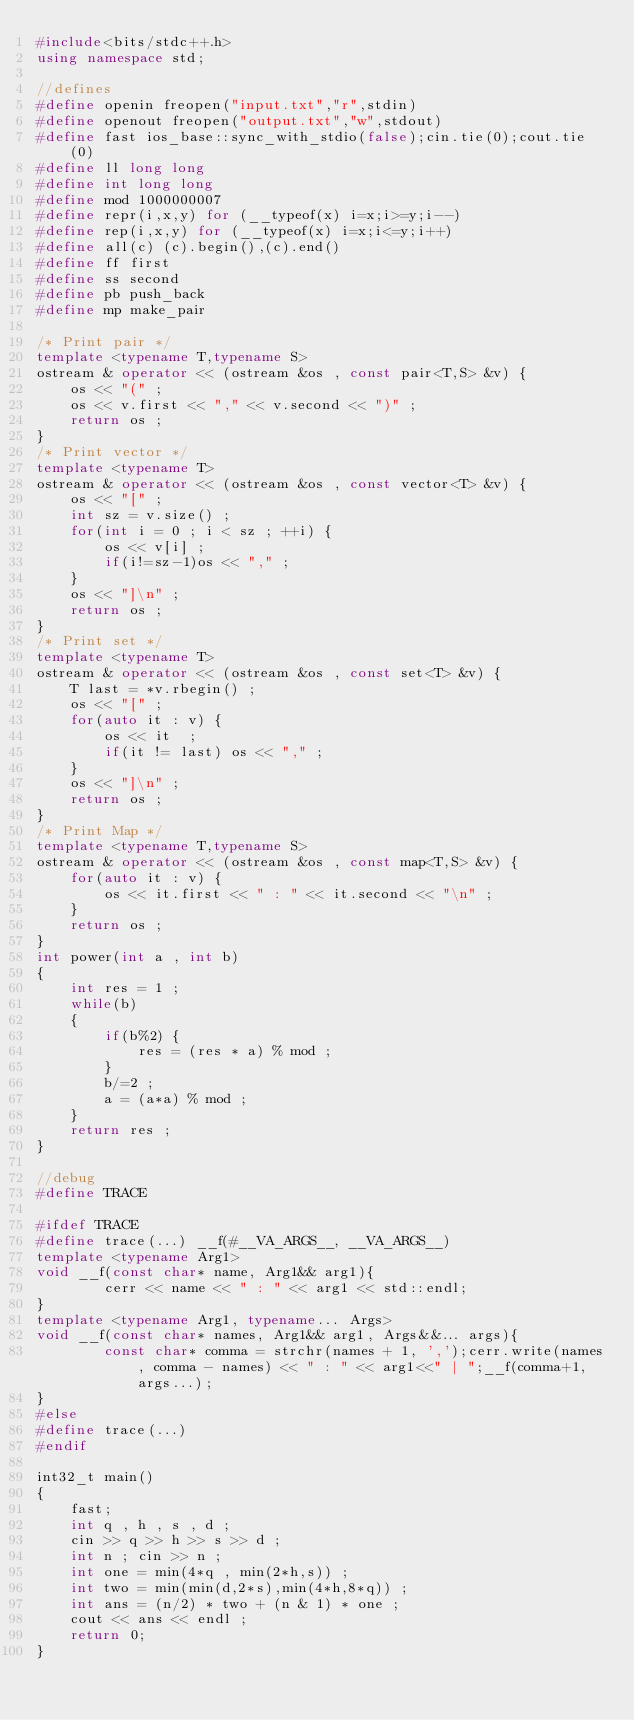Convert code to text. <code><loc_0><loc_0><loc_500><loc_500><_C++_>#include<bits/stdc++.h>
using namespace std;

//defines
#define openin freopen("input.txt","r",stdin)
#define openout freopen("output.txt","w",stdout)
#define fast ios_base::sync_with_stdio(false);cin.tie(0);cout.tie(0)
#define ll long long
#define int long long
#define mod 1000000007
#define repr(i,x,y) for (__typeof(x) i=x;i>=y;i--)
#define rep(i,x,y) for (__typeof(x) i=x;i<=y;i++)
#define all(c) (c).begin(),(c).end()
#define ff first
#define ss second
#define pb push_back
#define mp make_pair

/* Print pair */
template <typename T,typename S>
ostream & operator << (ostream &os , const pair<T,S> &v) {
    os << "(" ;
    os << v.first << "," << v.second << ")" ;
    return os ;
}
/* Print vector */
template <typename T>
ostream & operator << (ostream &os , const vector<T> &v) {
    os << "[" ;
    int sz = v.size() ;
    for(int i = 0 ; i < sz ; ++i) {
        os << v[i] ;
        if(i!=sz-1)os << "," ;
    }
    os << "]\n" ;
    return os ;
}
/* Print set */
template <typename T>
ostream & operator << (ostream &os , const set<T> &v) {
    T last = *v.rbegin() ;
    os << "[" ;
    for(auto it : v) {
        os << it  ;
        if(it != last) os << "," ;
    }
    os << "]\n" ;
    return os ;
}
/* Print Map */
template <typename T,typename S>
ostream & operator << (ostream &os , const map<T,S> &v) {
    for(auto it : v) {
        os << it.first << " : " << it.second << "\n" ;
    }
    return os ;
}
int power(int a , int b)
{
    int res = 1 ;
    while(b)
    {
        if(b%2) {
            res = (res * a) % mod ;
        }
        b/=2 ;
        a = (a*a) % mod ;
    }
    return res ;
}

//debug
#define TRACE

#ifdef TRACE
#define trace(...) __f(#__VA_ARGS__, __VA_ARGS__)
template <typename Arg1>
void __f(const char* name, Arg1&& arg1){
        cerr << name << " : " << arg1 << std::endl;
}
template <typename Arg1, typename... Args>
void __f(const char* names, Arg1&& arg1, Args&&... args){
        const char* comma = strchr(names + 1, ',');cerr.write(names, comma - names) << " : " << arg1<<" | ";__f(comma+1, args...);
}
#else
#define trace(...)
#endif

int32_t main()
{
    fast;
    int q , h , s , d ; 
    cin >> q >> h >> s >> d ; 
    int n ; cin >> n ; 
    int one = min(4*q , min(2*h,s)) ;
    int two = min(min(d,2*s),min(4*h,8*q)) ; 
    int ans = (n/2) * two + (n & 1) * one ; 
    cout << ans << endl ; 
    return 0;
}
</code> 